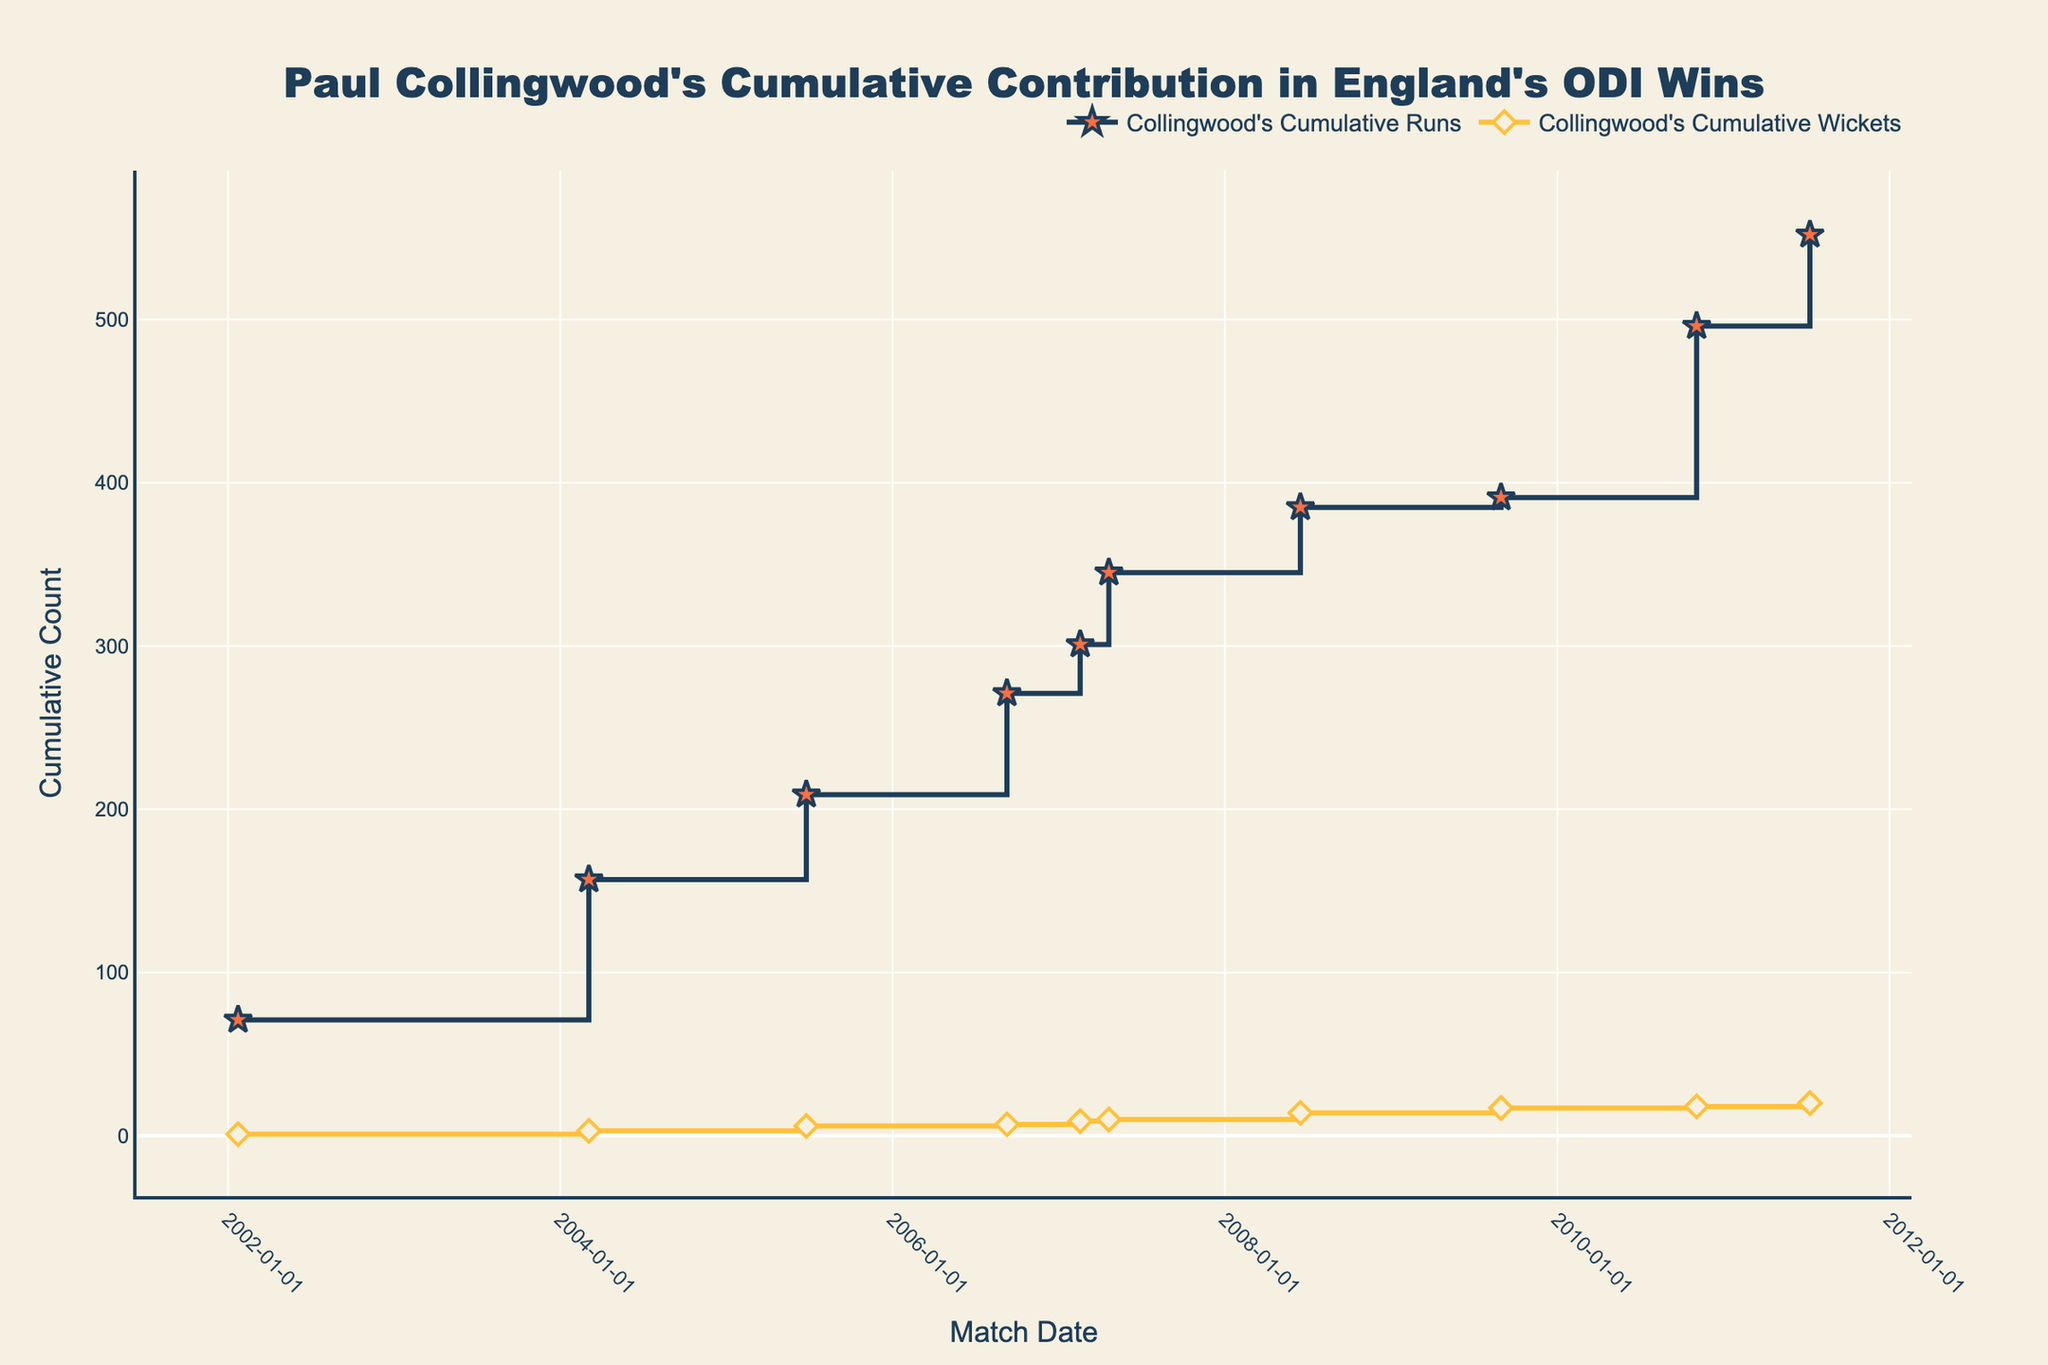When was Paul Collingwood's highest individual run contribution in England's ODI wins? Look at the figure where Collingwood's cumulative runs show the steepest increase. This occurs at a specific match date, which indicates the highest individual run contribution.
Answer: 2010-11-03 In which match did Paul Collingwood's cumulative runs first exceed 100? Trace the cumulative runs graph to find the point where it first surpasses 100. Identify the match date corresponding to this point.
Answer: 2004-03-04 How many runs did Paul Collingwood score in total across these selected matches? Look at the final value on the Collingwood’s Cumulative Runs line by the last match date. This value represents his total runs.
Answer: 552 How many matches does the plot represent for Paul Collingwood's contribution in England's ODI wins? Count the number of data points or markers present on the x-axis of the plot. Each marker represents a match.
Answer: 10 In which match did Paul Collingwood take the most wickets? Identify the point where the largest vertical jump occurs on the cumulative wickets graph. This indicates the match with the highest number of wickets taken.
Answer: 2008-06-15 By the end of the series, what was the total number of wickets taken by Paul Collingwood? Observe the final value on the Collingwood’s Cumulative Wickets line. This value represents the total number of wickets taken.
Answer: 20 How does Paul Collingwood's cumulative runs compare to his cumulative wickets by the last match? Compare the final values of the two lines representing cumulative runs and cumulative wickets.
Answer: More runs than wickets On which date did Collingwood's cumulative runs double for the first time after the initial match? Look for the point on the cumulative runs line where the value is first twice the initial value (i.e., twice his contribution in the 2002-01-23 match). Identify the date at this point.
Answer: 2004-03-04 In which match did Paul Collingwood contribute both significantly in runs and wickets, and how can it be identified from the plot? Identify points where both cumulative lines (runs and wickets) show a noticeable vertical jump, indicating significant contributions in both aspects.
Answer: 2008-06-15 Between which two consecutive matches did Paul Collingwood achieve the highest increment in his cumulative runs? Look for the steepest segment between any two consecutive points on the cumulative runs graph. The match dates at the beginning and end of this segment are the required matches.
Answer: 2010-11-03 and 2011-07-10 